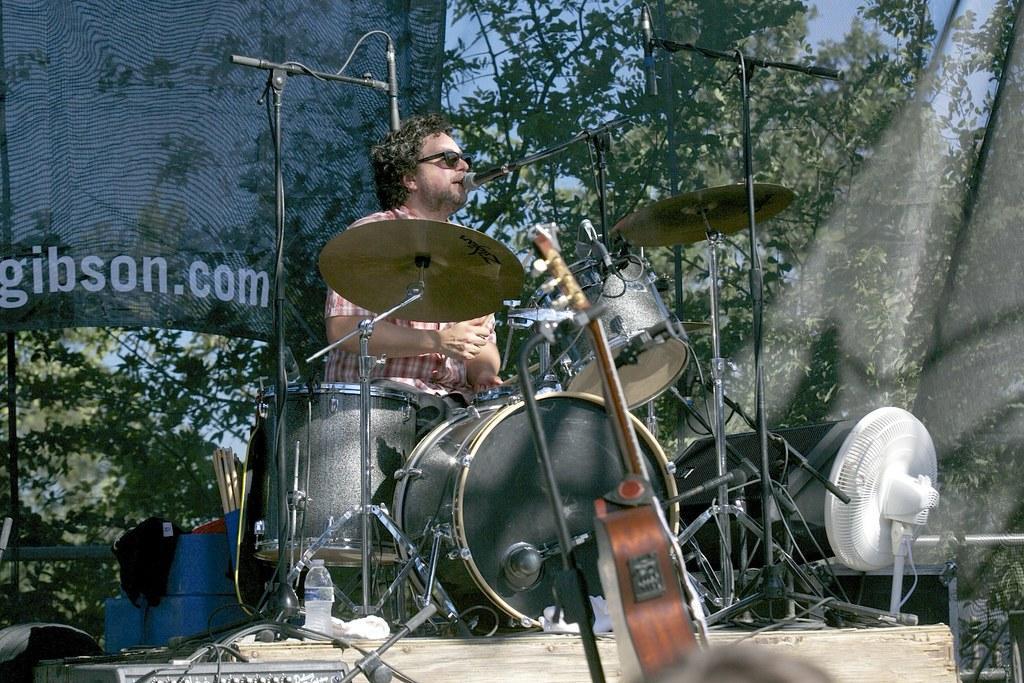Can you describe this image briefly? In this image there is a man in the middle. In front of him there is a mic and a band which contains drums,musical plates. At the bottom there is a fan. In the middle there is a guitar. On the left side bottom there are speakers. Beside the speakers there is a bottle. In the background there is a banner. Beside the banner there are trees. At the bottom there are sticks and boxes. 